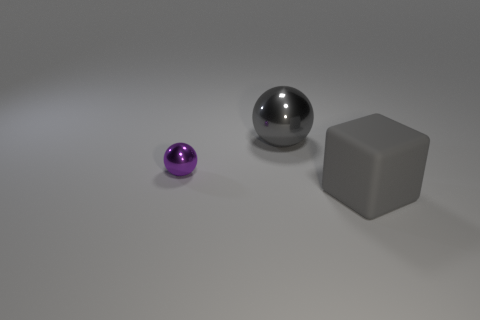Add 1 blocks. How many objects exist? 4 Subtract all blocks. How many objects are left? 2 Add 2 big things. How many big things exist? 4 Subtract 0 yellow cubes. How many objects are left? 3 Subtract all gray objects. Subtract all large yellow spheres. How many objects are left? 1 Add 3 gray matte objects. How many gray matte objects are left? 4 